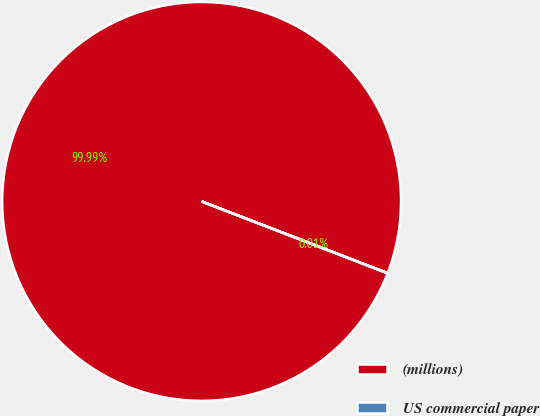Convert chart. <chart><loc_0><loc_0><loc_500><loc_500><pie_chart><fcel>(millions)<fcel>US commercial paper<nl><fcel>99.99%<fcel>0.01%<nl></chart> 